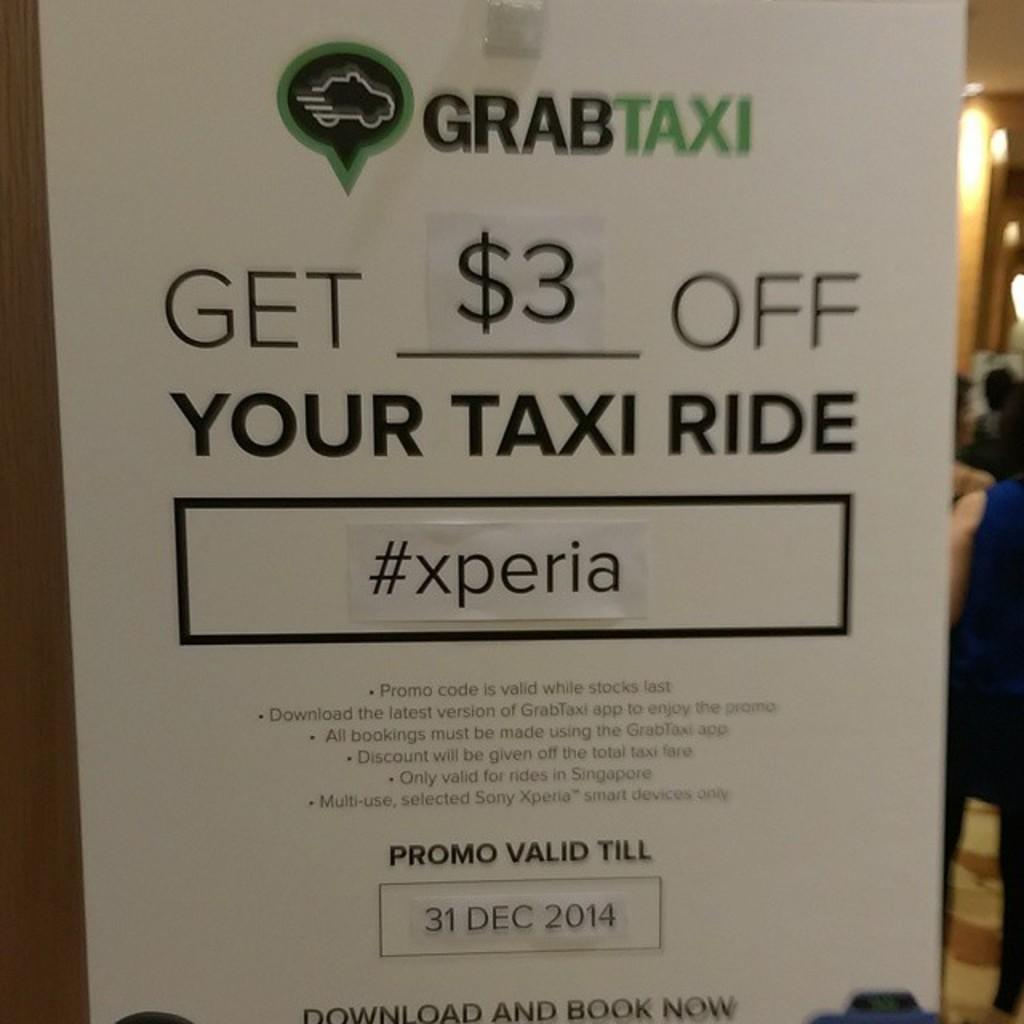<image>
Provide a brief description of the given image. A posted advertisement for GRABTAXI that states you can get $3 off a taxi ride. 